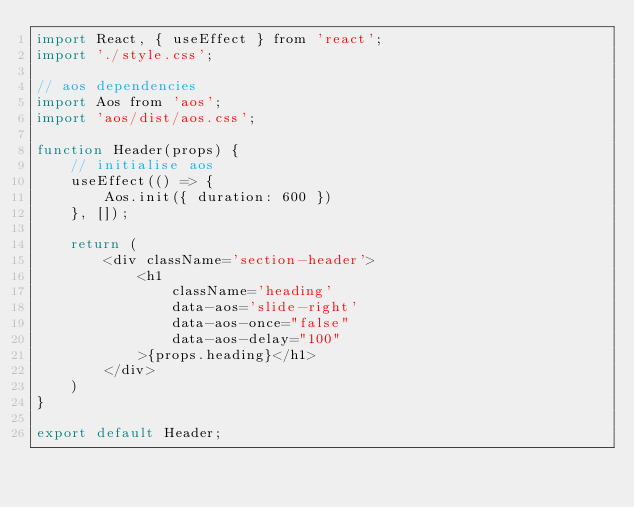<code> <loc_0><loc_0><loc_500><loc_500><_JavaScript_>import React, { useEffect } from 'react';
import './style.css';

// aos dependencies
import Aos from 'aos';
import 'aos/dist/aos.css';

function Header(props) {
    // initialise aos
    useEffect(() => {
        Aos.init({ duration: 600 })
    }, []);

    return (
        <div className='section-header'>
            <h1
                className='heading'
                data-aos='slide-right'
                data-aos-once="false"
                data-aos-delay="100"
            >{props.heading}</h1>
        </div>
    )
}

export default Header;
</code> 